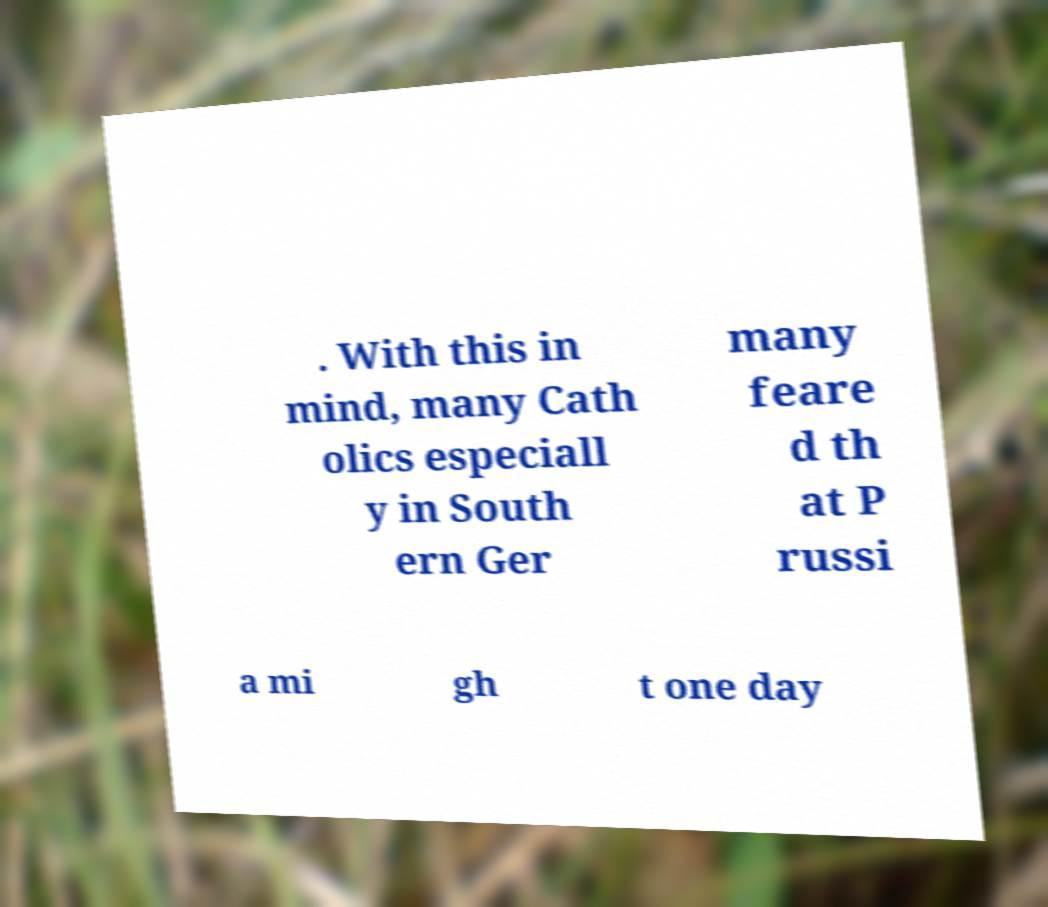There's text embedded in this image that I need extracted. Can you transcribe it verbatim? . With this in mind, many Cath olics especiall y in South ern Ger many feare d th at P russi a mi gh t one day 